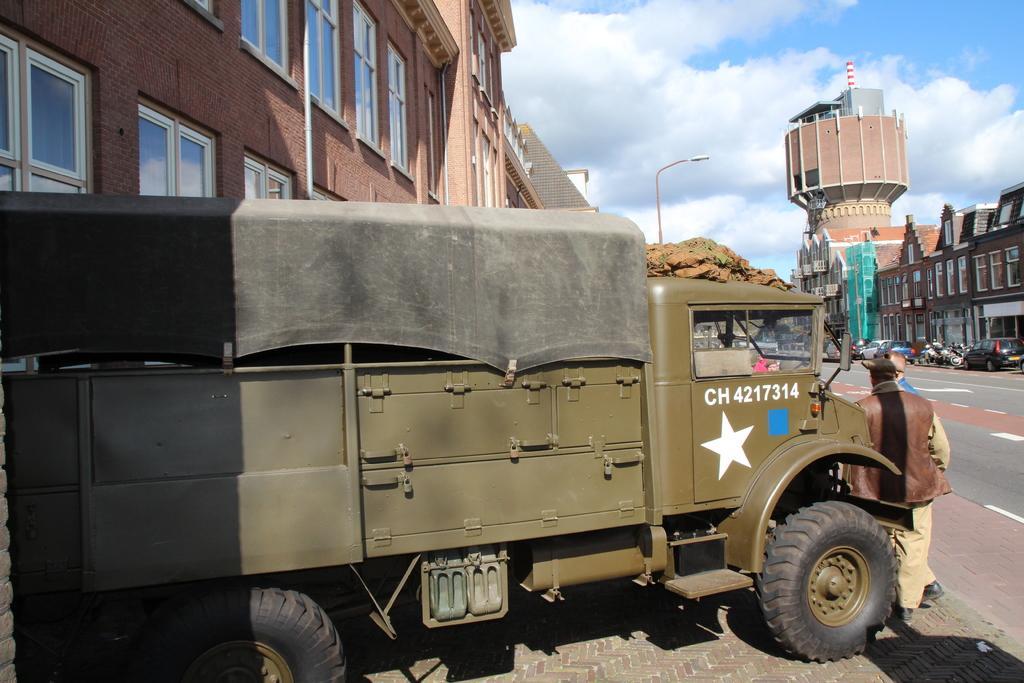Please provide a concise description of this image. In this picture there is a man who is standing near to the track. On the right I can see the cars and bikes which are parked near to the building, beside them I can see the street lights. At the top I can see the sky and clouds. 